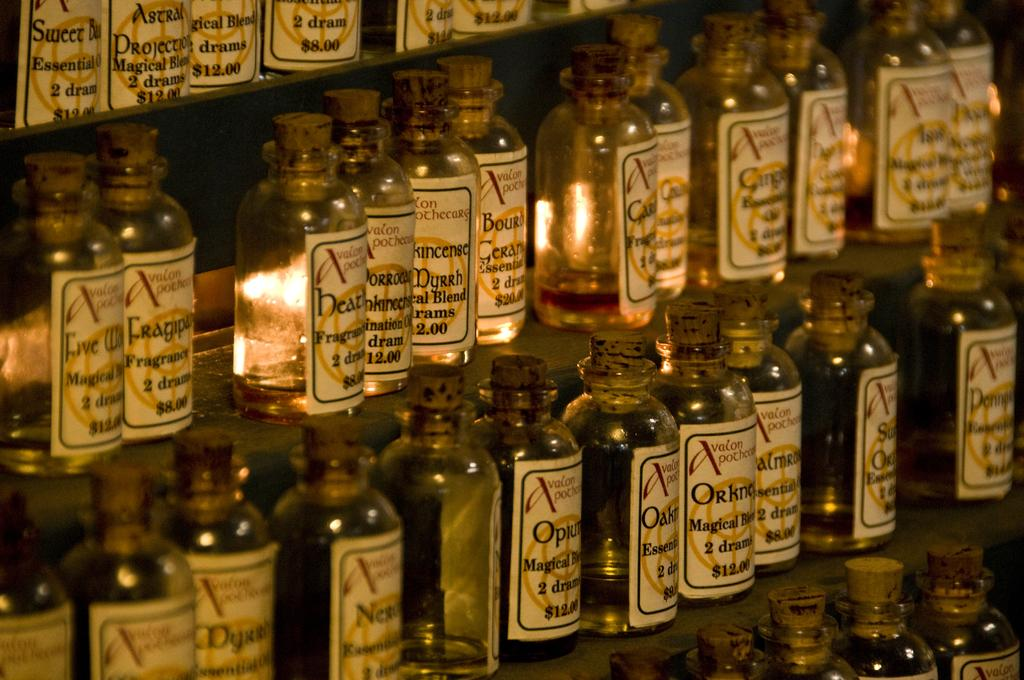Provide a one-sentence caption for the provided image. Many bottles for sale with the top left one being $12. 